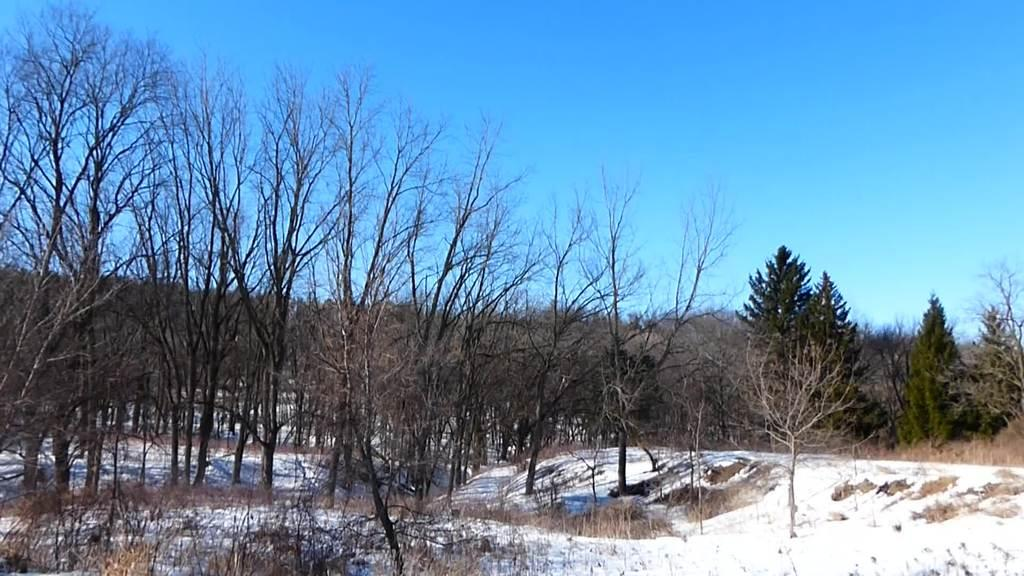What can be seen in the sky in the image? The sky is visible in the image. What type of vegetation is present in the image? There are trees and plants in the image. What is covering the ground in the image? The ground is covered with snow in the image. What type of alarm can be heard going off in the image? There is no alarm present in the image, as it is a still image and cannot produce sound. 